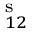<formula> <loc_0><loc_0><loc_500><loc_500>^ { s } _ { 1 2 }</formula> 